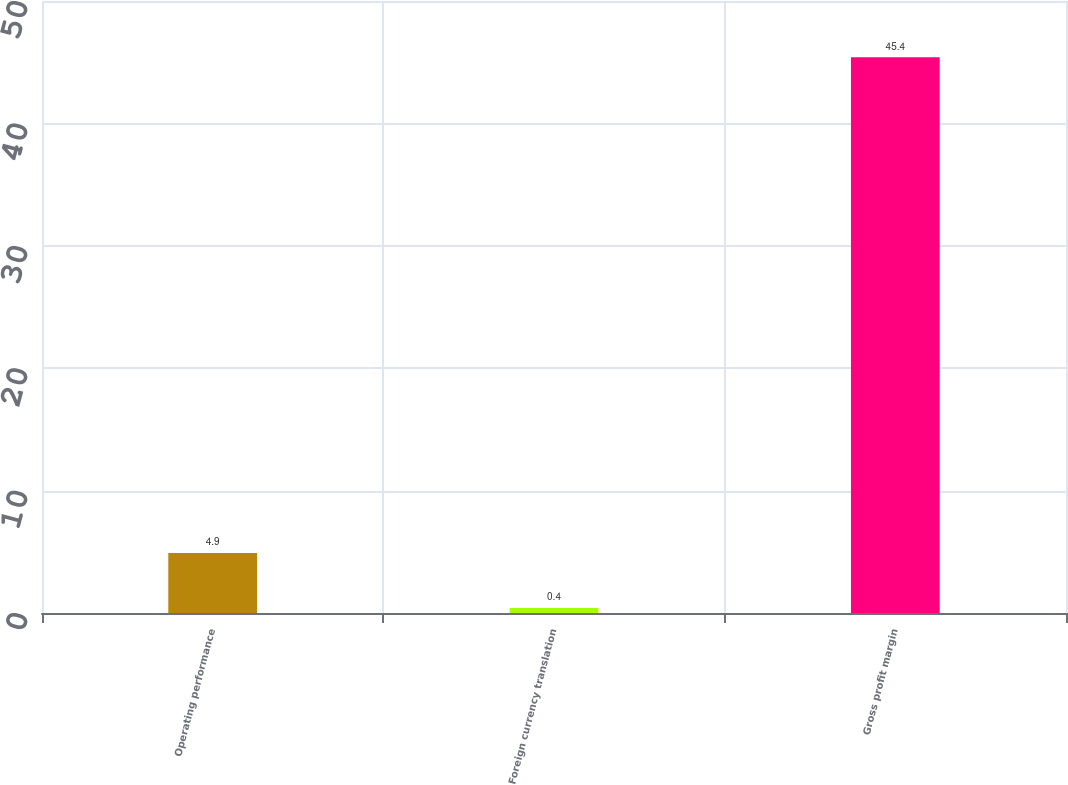Convert chart. <chart><loc_0><loc_0><loc_500><loc_500><bar_chart><fcel>Operating performance<fcel>Foreign currency translation<fcel>Gross profit margin<nl><fcel>4.9<fcel>0.4<fcel>45.4<nl></chart> 